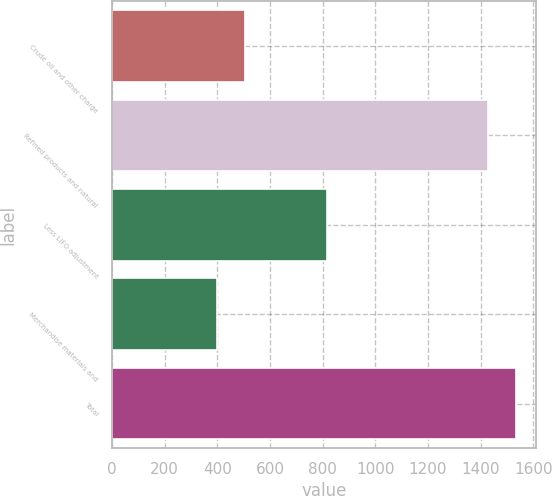Convert chart. <chart><loc_0><loc_0><loc_500><loc_500><bar_chart><fcel>Crude oil and other charge<fcel>Refined products and natural<fcel>Less LIFO adjustment<fcel>Merchandise materials and<fcel>Total<nl><fcel>503.8<fcel>1429<fcel>815<fcel>400<fcel>1532.8<nl></chart> 